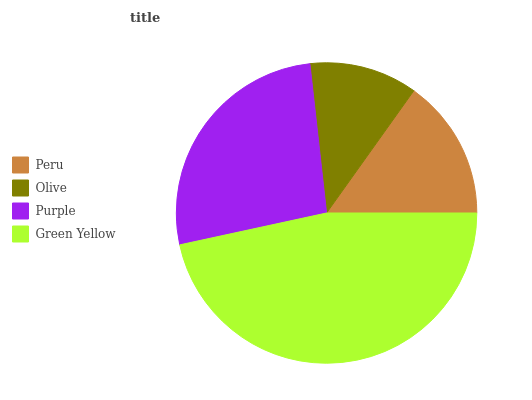Is Olive the minimum?
Answer yes or no. Yes. Is Green Yellow the maximum?
Answer yes or no. Yes. Is Purple the minimum?
Answer yes or no. No. Is Purple the maximum?
Answer yes or no. No. Is Purple greater than Olive?
Answer yes or no. Yes. Is Olive less than Purple?
Answer yes or no. Yes. Is Olive greater than Purple?
Answer yes or no. No. Is Purple less than Olive?
Answer yes or no. No. Is Purple the high median?
Answer yes or no. Yes. Is Peru the low median?
Answer yes or no. Yes. Is Green Yellow the high median?
Answer yes or no. No. Is Purple the low median?
Answer yes or no. No. 